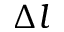Convert formula to latex. <formula><loc_0><loc_0><loc_500><loc_500>\Delta l</formula> 